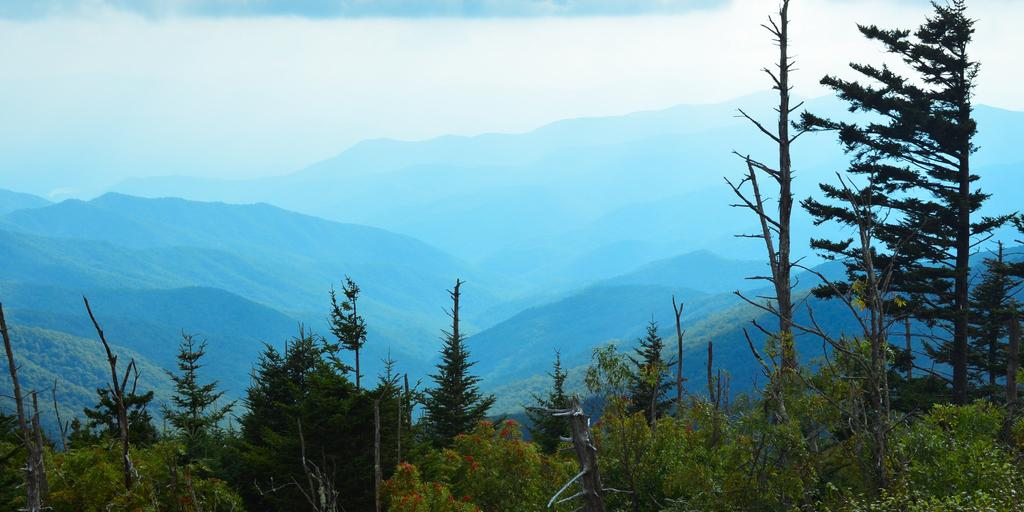What geographical feature is located in the center of the image? There are mountains in the center of the image. What type of vegetation is present at the bottom of the image? Trees and flowers are visible at the bottom of the image. What can be seen in the sky at the top of the image? Clouds are present in the sky at the top of the image. What type of guitar is being played in the image? There is no guitar present in the image; it features mountains, trees, flowers, and clouds. What property is visible in the image? There is no property visible in the image; it focuses on natural elements such as mountains, trees, flowers, and clouds. 